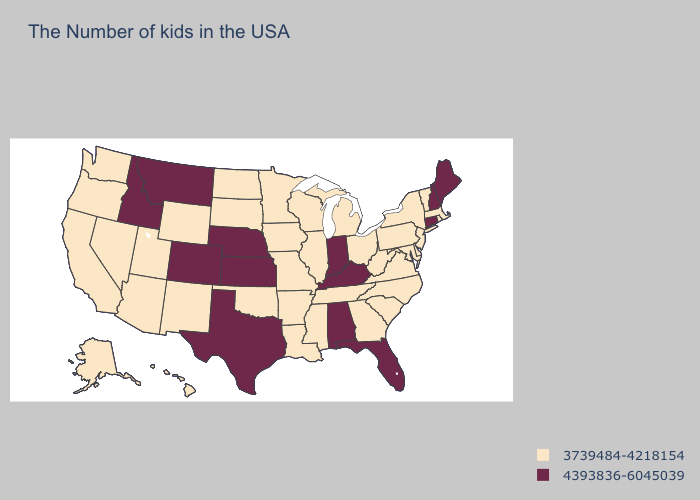Which states have the highest value in the USA?
Keep it brief. Maine, New Hampshire, Connecticut, Florida, Kentucky, Indiana, Alabama, Kansas, Nebraska, Texas, Colorado, Montana, Idaho. What is the highest value in states that border Florida?
Give a very brief answer. 4393836-6045039. Which states have the lowest value in the USA?
Be succinct. Massachusetts, Rhode Island, Vermont, New York, New Jersey, Delaware, Maryland, Pennsylvania, Virginia, North Carolina, South Carolina, West Virginia, Ohio, Georgia, Michigan, Tennessee, Wisconsin, Illinois, Mississippi, Louisiana, Missouri, Arkansas, Minnesota, Iowa, Oklahoma, South Dakota, North Dakota, Wyoming, New Mexico, Utah, Arizona, Nevada, California, Washington, Oregon, Alaska, Hawaii. Among the states that border Arkansas , does Texas have the highest value?
Keep it brief. Yes. Name the states that have a value in the range 4393836-6045039?
Write a very short answer. Maine, New Hampshire, Connecticut, Florida, Kentucky, Indiana, Alabama, Kansas, Nebraska, Texas, Colorado, Montana, Idaho. What is the value of Kentucky?
Quick response, please. 4393836-6045039. What is the value of Louisiana?
Short answer required. 3739484-4218154. Name the states that have a value in the range 4393836-6045039?
Give a very brief answer. Maine, New Hampshire, Connecticut, Florida, Kentucky, Indiana, Alabama, Kansas, Nebraska, Texas, Colorado, Montana, Idaho. How many symbols are there in the legend?
Answer briefly. 2. Name the states that have a value in the range 4393836-6045039?
Concise answer only. Maine, New Hampshire, Connecticut, Florida, Kentucky, Indiana, Alabama, Kansas, Nebraska, Texas, Colorado, Montana, Idaho. How many symbols are there in the legend?
Short answer required. 2. What is the highest value in states that border Louisiana?
Short answer required. 4393836-6045039. Among the states that border Nebraska , which have the lowest value?
Short answer required. Missouri, Iowa, South Dakota, Wyoming. What is the value of Nebraska?
Short answer required. 4393836-6045039. Among the states that border New York , does Connecticut have the lowest value?
Answer briefly. No. 